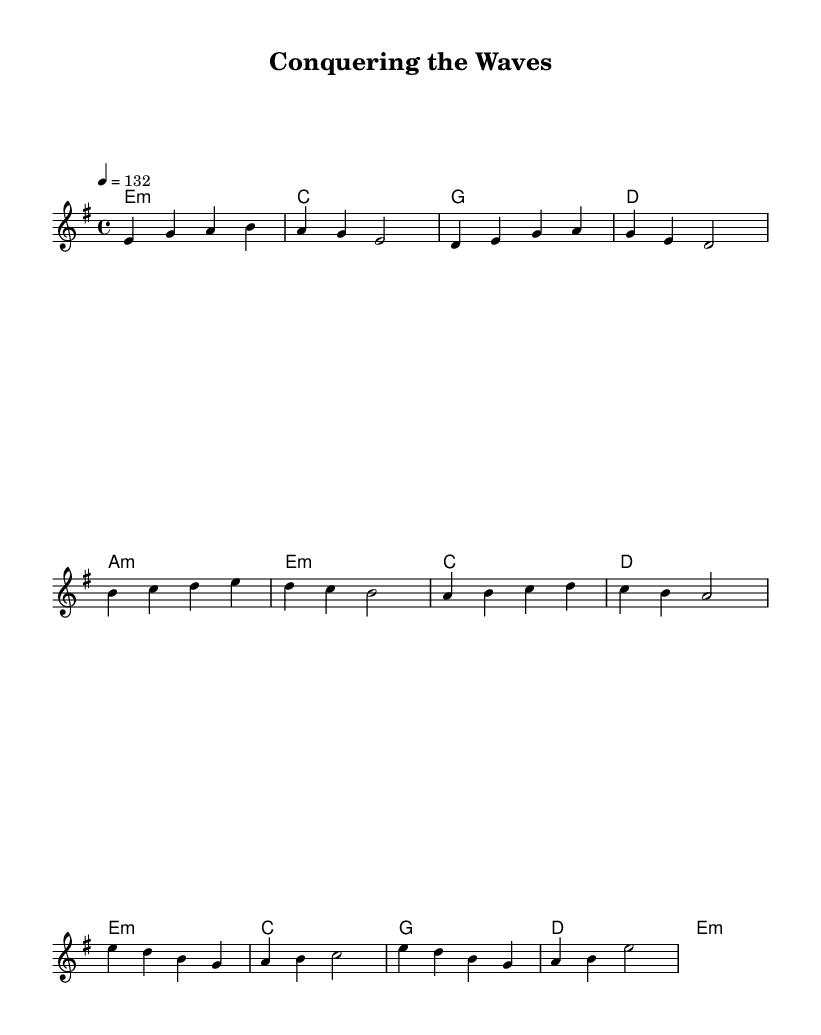What is the key signature of this music? The key signature appears to be E minor, indicated by one sharp (F#). This is confirmed by looking at the global music settings in the sheet, specifically in the line stating `\key e \minor`.
Answer: E minor What is the time signature of this music? The time signature is indicated as 4/4, shown in the global settings with the line `\time 4/4`. This means there are four beats in each measure and the quarter note receives one beat.
Answer: 4/4 What is the tempo marking of the piece? The tempo marking of the piece is given as 4 = 132, which means there are 132 beats per minute. This is specified in the global settings as `\tempo 4 = 132`.
Answer: 132 How many measures are present in the chorus? The chorus consists of two separate phrases, each containing four measures, making a total of eight measures in the chorus. This can be counted from the provided music lines in the sheet music.
Answer: 8 What type of music does this sheet correspond to? This sheet corresponds to Latin rock, as indicated by the theme of overcoming challenges and achieving victory, which is typical of this genre's lyrical content and energetic rhythms.
Answer: Latin rock What is the chord progression used in the verse section? The chord progression in the verse consists of E minor, C, G, and D, which can be observed in the harmonies section labeled under the verse, showing a distinct sequence that supports the melody.
Answer: E minor, C, G, D How does the melody in the pre-chorus differ from the verse? The melody in the pre-chorus employs a higher range of notes compared to the verse, indicated by the higher pitch notation from b to e in the pre-chorus versus lower pitches in the verse.
Answer: Higher pitch 